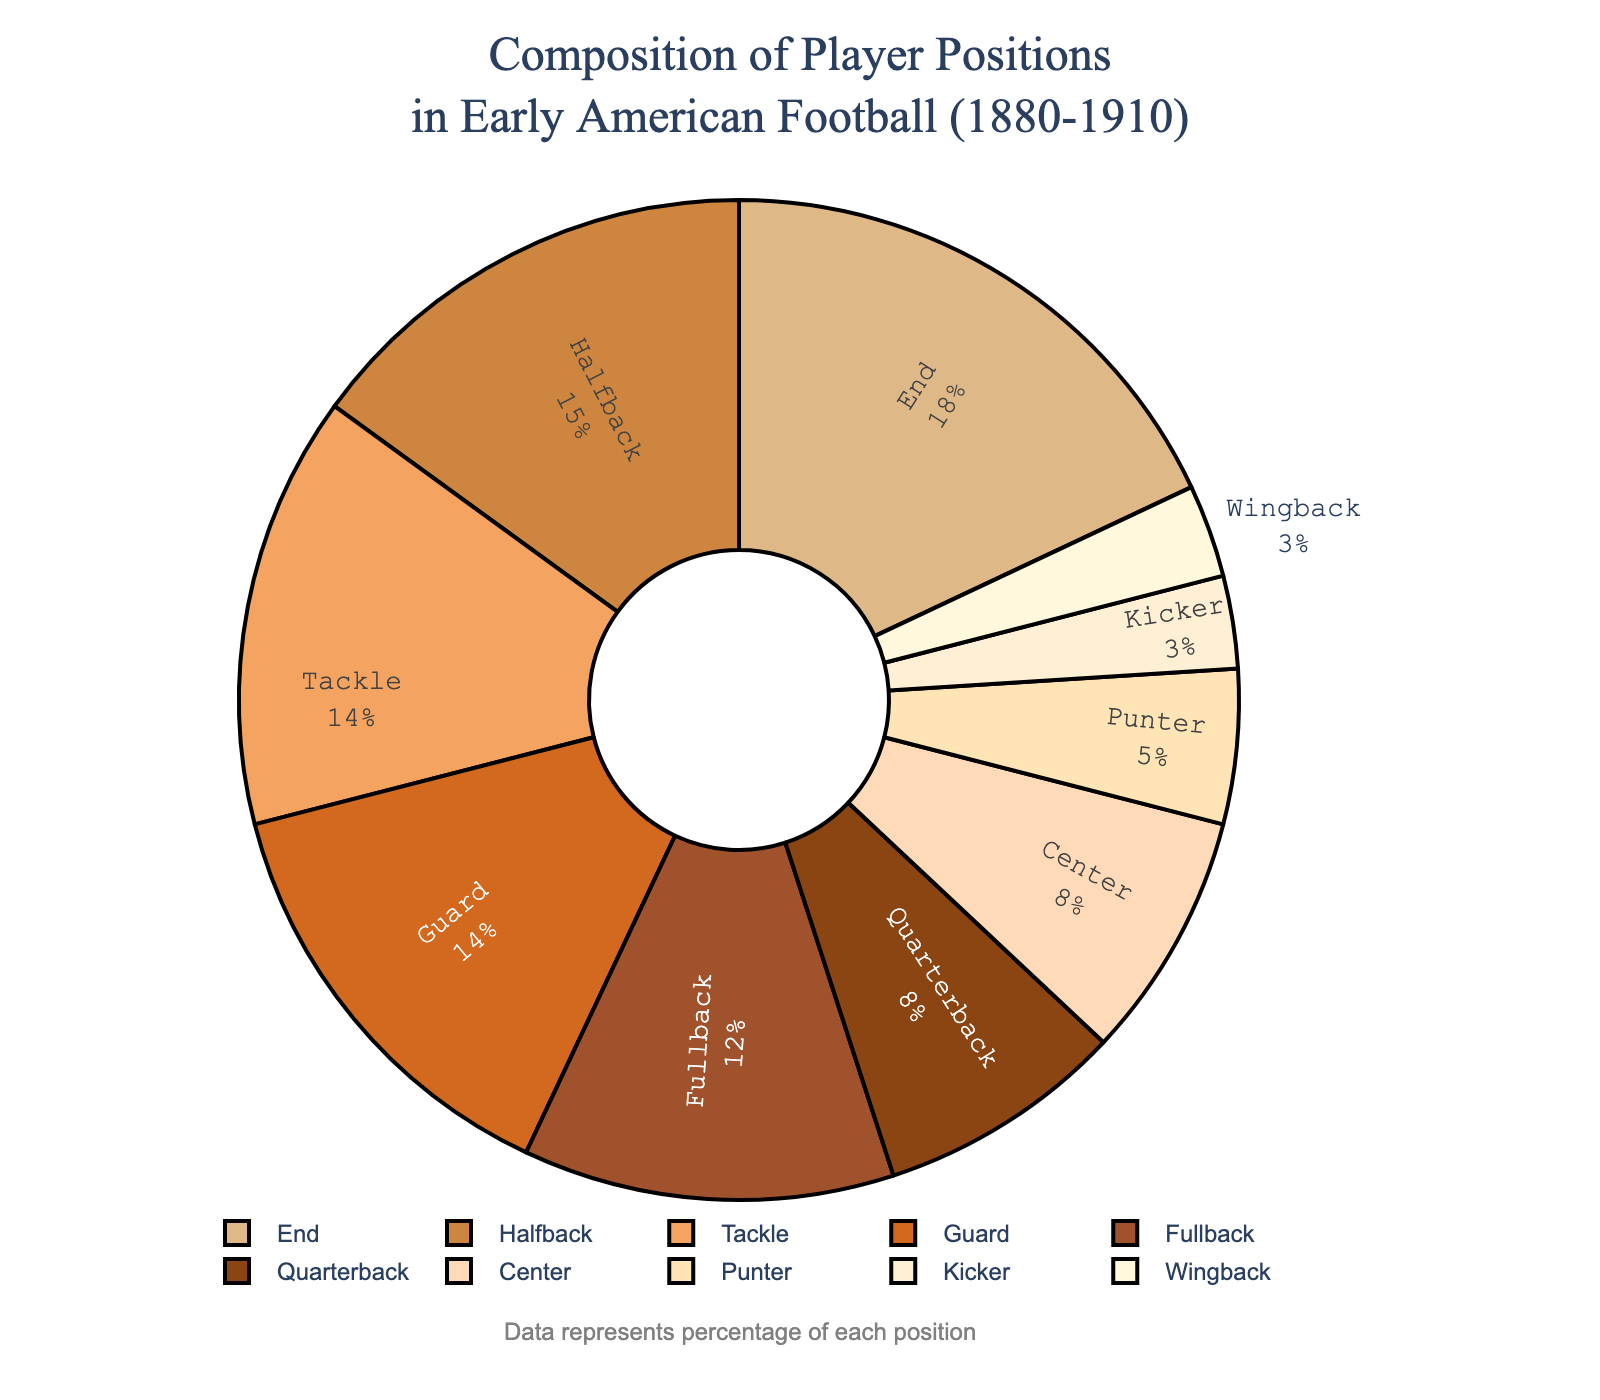What player position has the highest percentage of composition? The player position with the largest slice in the pie chart represents the highest percentage. The "End" position has the largest slice, indicating it has the highest composition.
Answer: End What's the combined percentage of Fullback and Halfback positions? To find the combined percentage, add the percentages for Fullback and Halfback positions. Fullback is 12% and Halfback is 15%. Therefore, 12% + 15% = 27%.
Answer: 27% Are there more positions with a percentage greater than or equal to 10% or less than 10%? Count the number of positions with percentages >= 10% and those < 10%. Positions >= 10%: Quarterback, Fullback, Halfback, End, Tackle, Guard, Center (7 positions). Positions < 10%: Punter, Kicker, Wingback (3 positions). Therefore, there are more positions with >= 10%.
Answer: Greater than or equal to 10% Which position is represented in red, and what is its percentage? The red slice in the pie chart represents the Quarterback position. The percentage label next to it shows 8%.
Answer: Quarterback, 8% How much smaller is the percentage of Kicker compared to Halfback? Calculate the difference between the percentages of Halfback and Kicker. Halfback is 15% and Kicker is 3%. Therefore, 15% - 3% = 12%.
Answer: 12% What percentage of player positions are accounted for by both Guard and Tackle? Add the percentages for Guard and Tackle. Guard is 14% and Tackle is also 14%. Therefore, 14% + 14% = 28%.
Answer: 28% If Wingback and Punter percentages were combined, would their total be higher than Fullback? Calculate the combined percentage of Wingback and Punter and compare it to Fullback. Wingback is 3% and Punter is 5%, giving a total of 3% + 5% = 8%. Fullback is 12%. Therefore, 8% < 12%.
Answer: No Which position has the smallest slice and what is its exact value? The smallest slice corresponds to the position with the smallest percentage. The Kicker position appears to have the smallest slice and its percentage is 3%.
Answer: Kicker, 3% What is the difference between the percentage of Center and Fullback? Subtract the percentage of Center from that of Fullback. Fullback is 12%, and Center is 8%. Therefore, 12% - 8% = 4%.
Answer: 4% Which player positions are similar in percentage, and what are their values? Look for positions with nearly equal slices. Guard and Tackle both have a percentage of 14%. Additionally, Quarterback and Center both have a percentage of 8%.
Answer: Guard and Tackle: 14%; Quarterback and Center: 8% 